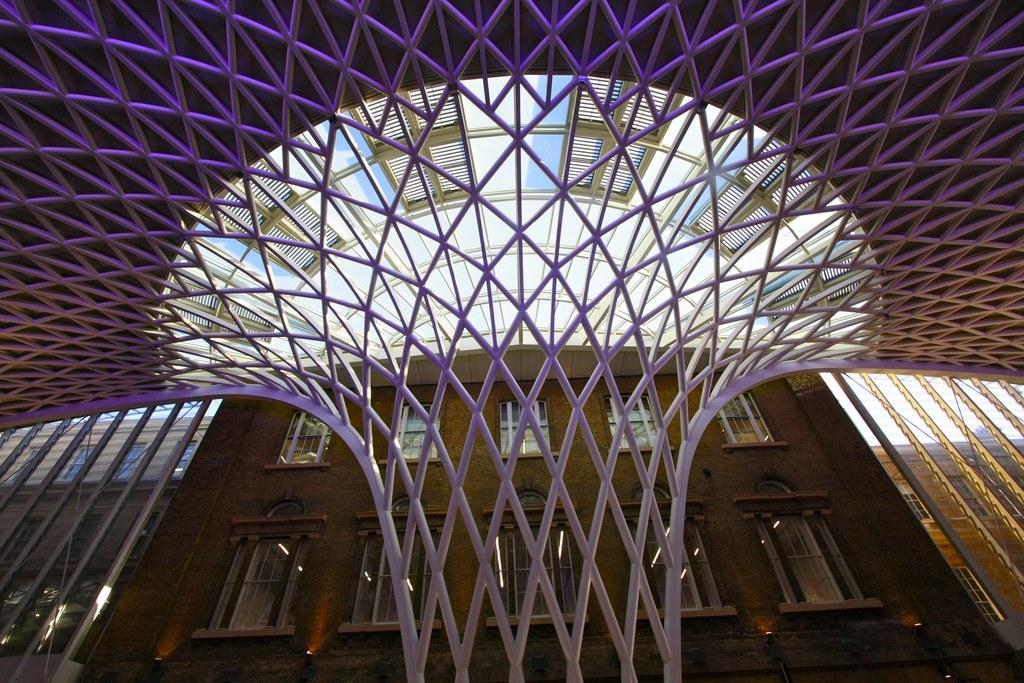How would you summarize this image in a sentence or two? In this image I can see a huge structure which is made up of metal rods and a building which is brown in color. I can see few windows of the building and the structure through which I can see the sky. 